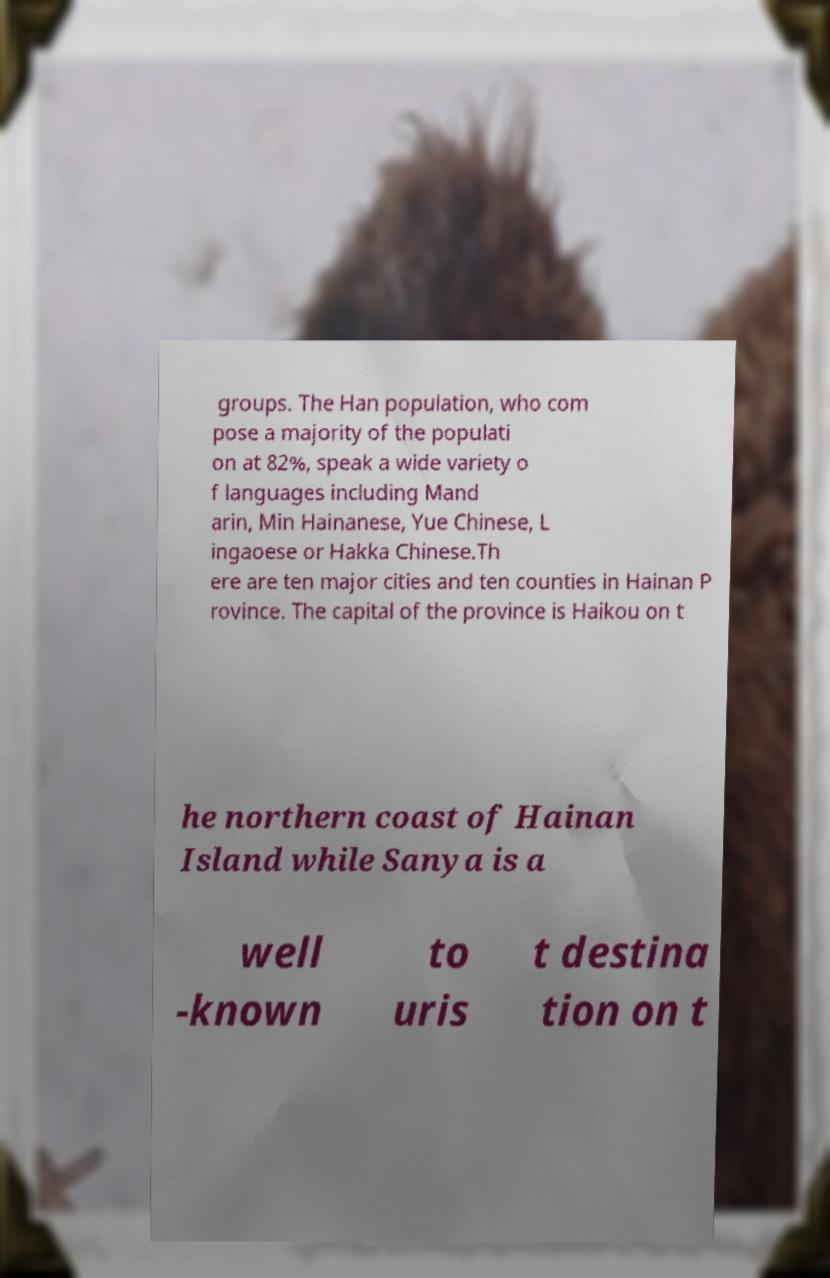Can you accurately transcribe the text from the provided image for me? groups. The Han population, who com pose a majority of the populati on at 82%, speak a wide variety o f languages including Mand arin, Min Hainanese, Yue Chinese, L ingaoese or Hakka Chinese.Th ere are ten major cities and ten counties in Hainan P rovince. The capital of the province is Haikou on t he northern coast of Hainan Island while Sanya is a well -known to uris t destina tion on t 